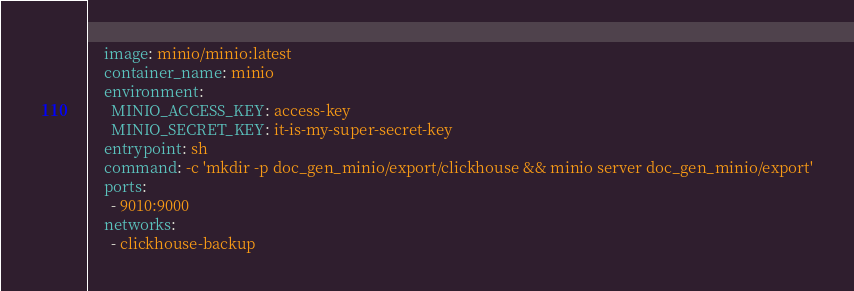Convert code to text. <code><loc_0><loc_0><loc_500><loc_500><_YAML_>    image: minio/minio:latest
    container_name: minio
    environment:
      MINIO_ACCESS_KEY: access-key
      MINIO_SECRET_KEY: it-is-my-super-secret-key
    entrypoint: sh
    command: -c 'mkdir -p doc_gen_minio/export/clickhouse && minio server doc_gen_minio/export'
    ports:
      - 9010:9000
    networks:
      - clickhouse-backup
</code> 